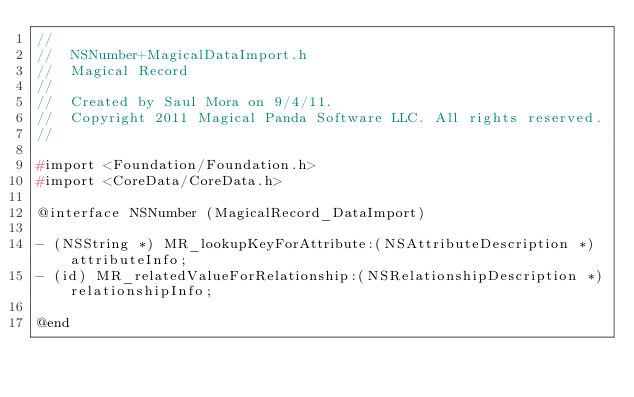<code> <loc_0><loc_0><loc_500><loc_500><_C_>//
//  NSNumber+MagicalDataImport.h
//  Magical Record
//
//  Created by Saul Mora on 9/4/11.
//  Copyright 2011 Magical Panda Software LLC. All rights reserved.
//

#import <Foundation/Foundation.h>
#import <CoreData/CoreData.h>

@interface NSNumber (MagicalRecord_DataImport)

- (NSString *) MR_lookupKeyForAttribute:(NSAttributeDescription *)attributeInfo;
- (id) MR_relatedValueForRelationship:(NSRelationshipDescription *)relationshipInfo;

@end
</code> 